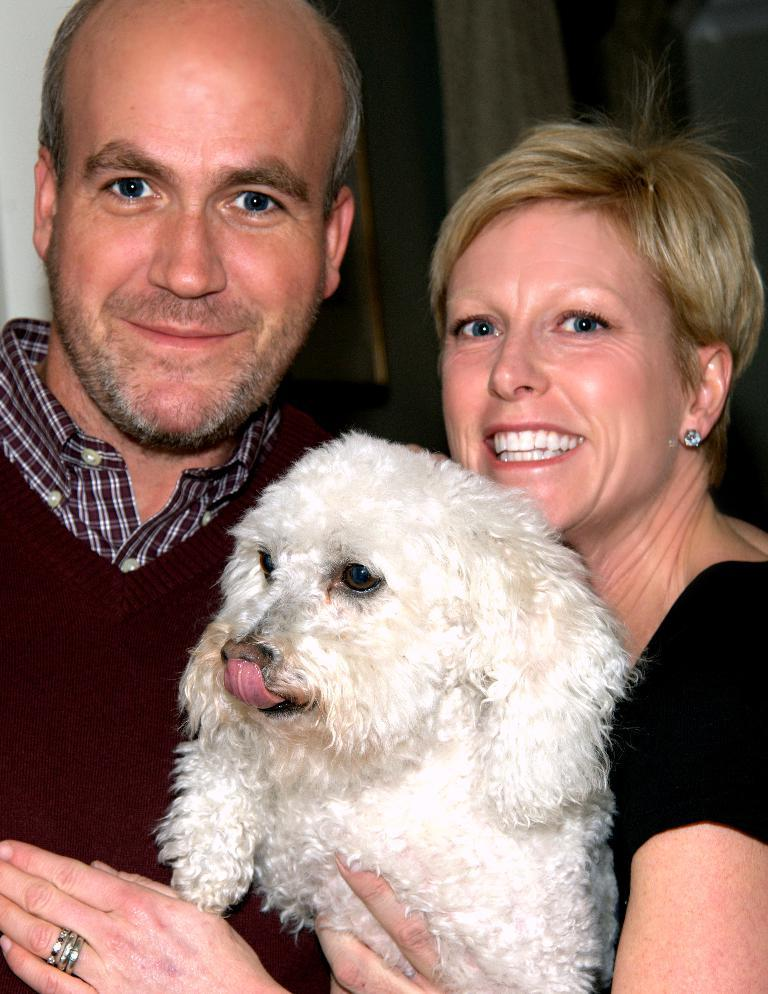What type of animal can be seen in the image? There is a dog in the image. Who else is present in the image besides the dog? There is a man and a woman in the image. What is the facial expression of the man and woman? The man and woman are smiling. What can be seen in the background of the image? There are objects in the background of the image. What type of songs is the dog singing in the image? There is no indication in the image that the dog is singing any songs, as dogs do not have the ability to sing. 